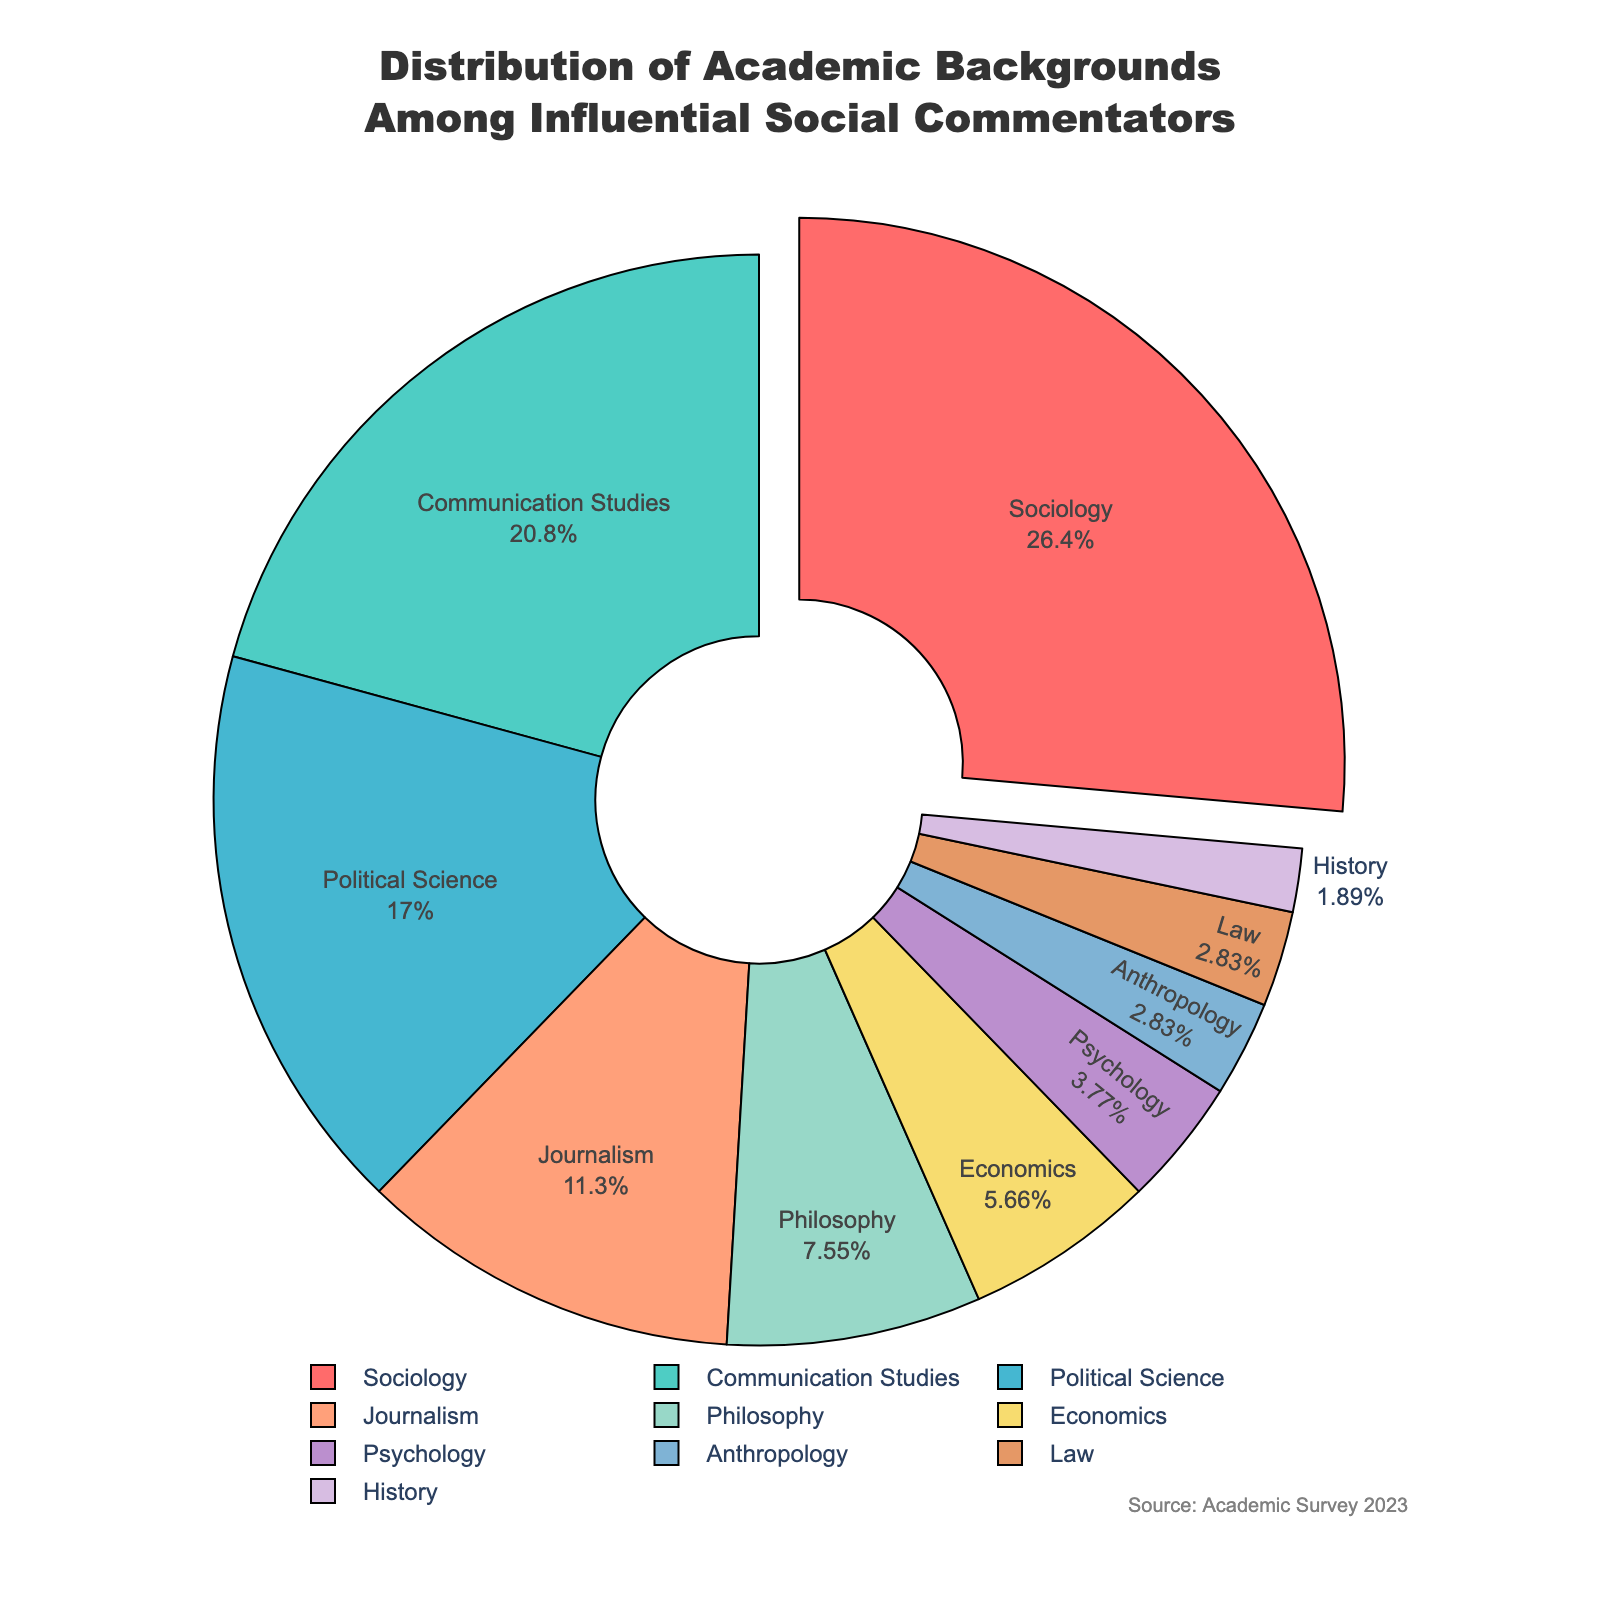What's the largest segment in the pie chart? The largest segment in the pie chart is pulled outward slightly from the center for emphasis. By looking closely, we can see that the segment representing Sociology takes up the most space.
Answer: Sociology Which two academic backgrounds combined have a nearly equal percentage as Sociology? Sociology makes up 28% of the pie chart. By adding up other percentages, we can see that Communication Studies (22%) and Psychology (4%) together amount to 26%, which is close to Sociology's percentage.
Answer: Communication Studies and Psychology What's the difference in percentage between Journalism and Political Science? Journalism accounts for 12% of the pie chart, while Political Science accounts for 18%. The difference between these two percentages is 18% - 12% = 6%.
Answer: 6% Which academic background has the smallest segment, and what is its percentage? The smallest segment in the pie chart belongs to History, making up 2% of the total. This can be identified by observing the segment with the least space.
Answer: History, 2% How do the combined percentages of Economics and Philosophy compare to Political Science? Economics and Philosophy have percentages of 6% and 8% respectively. Adding these together gives 6% + 8% = 14%. Political Science, by itself, has 18%. Therefore, Political Science has a higher percentage compared to the combined total of Economics and Philosophy.
Answer: Political Science is higher Which academic background is represented by the green segment, and what is its percentage? The green segment of the pie chart can be visually identified as representing Communication Studies. By referring to the visual cues, we see that Communication Studies makes up 22% of the chart.
Answer: Communication Studies, 22% What percentage of the chart do Sociology and Journalism make up together? Sociology is 28% and Journalism is 12%. Adding these percentages together gives 28% + 12% = 40%.
Answer: 40% If you sum the percentages of Philosophy, Economics, and Psychology, what is the total? Philosophy has 8%, Economics has 6%, and Psychology has 4%. Summing these values: 8% + 6% + 4% = 18%.
Answer: 18% Which academic backgrounds have the same percentage, and what is that percentage? Both Anthropology and Law each make up 3% of the pie chart, thus having the same percentage.
Answer: Anthropology and Law, 3% What is the percentage difference between the two smallest academic backgrounds? The two smallest segments are History (2%) and Anthropology (3%). The difference between these percentages is 3% - 2% = 1%.
Answer: 1% 